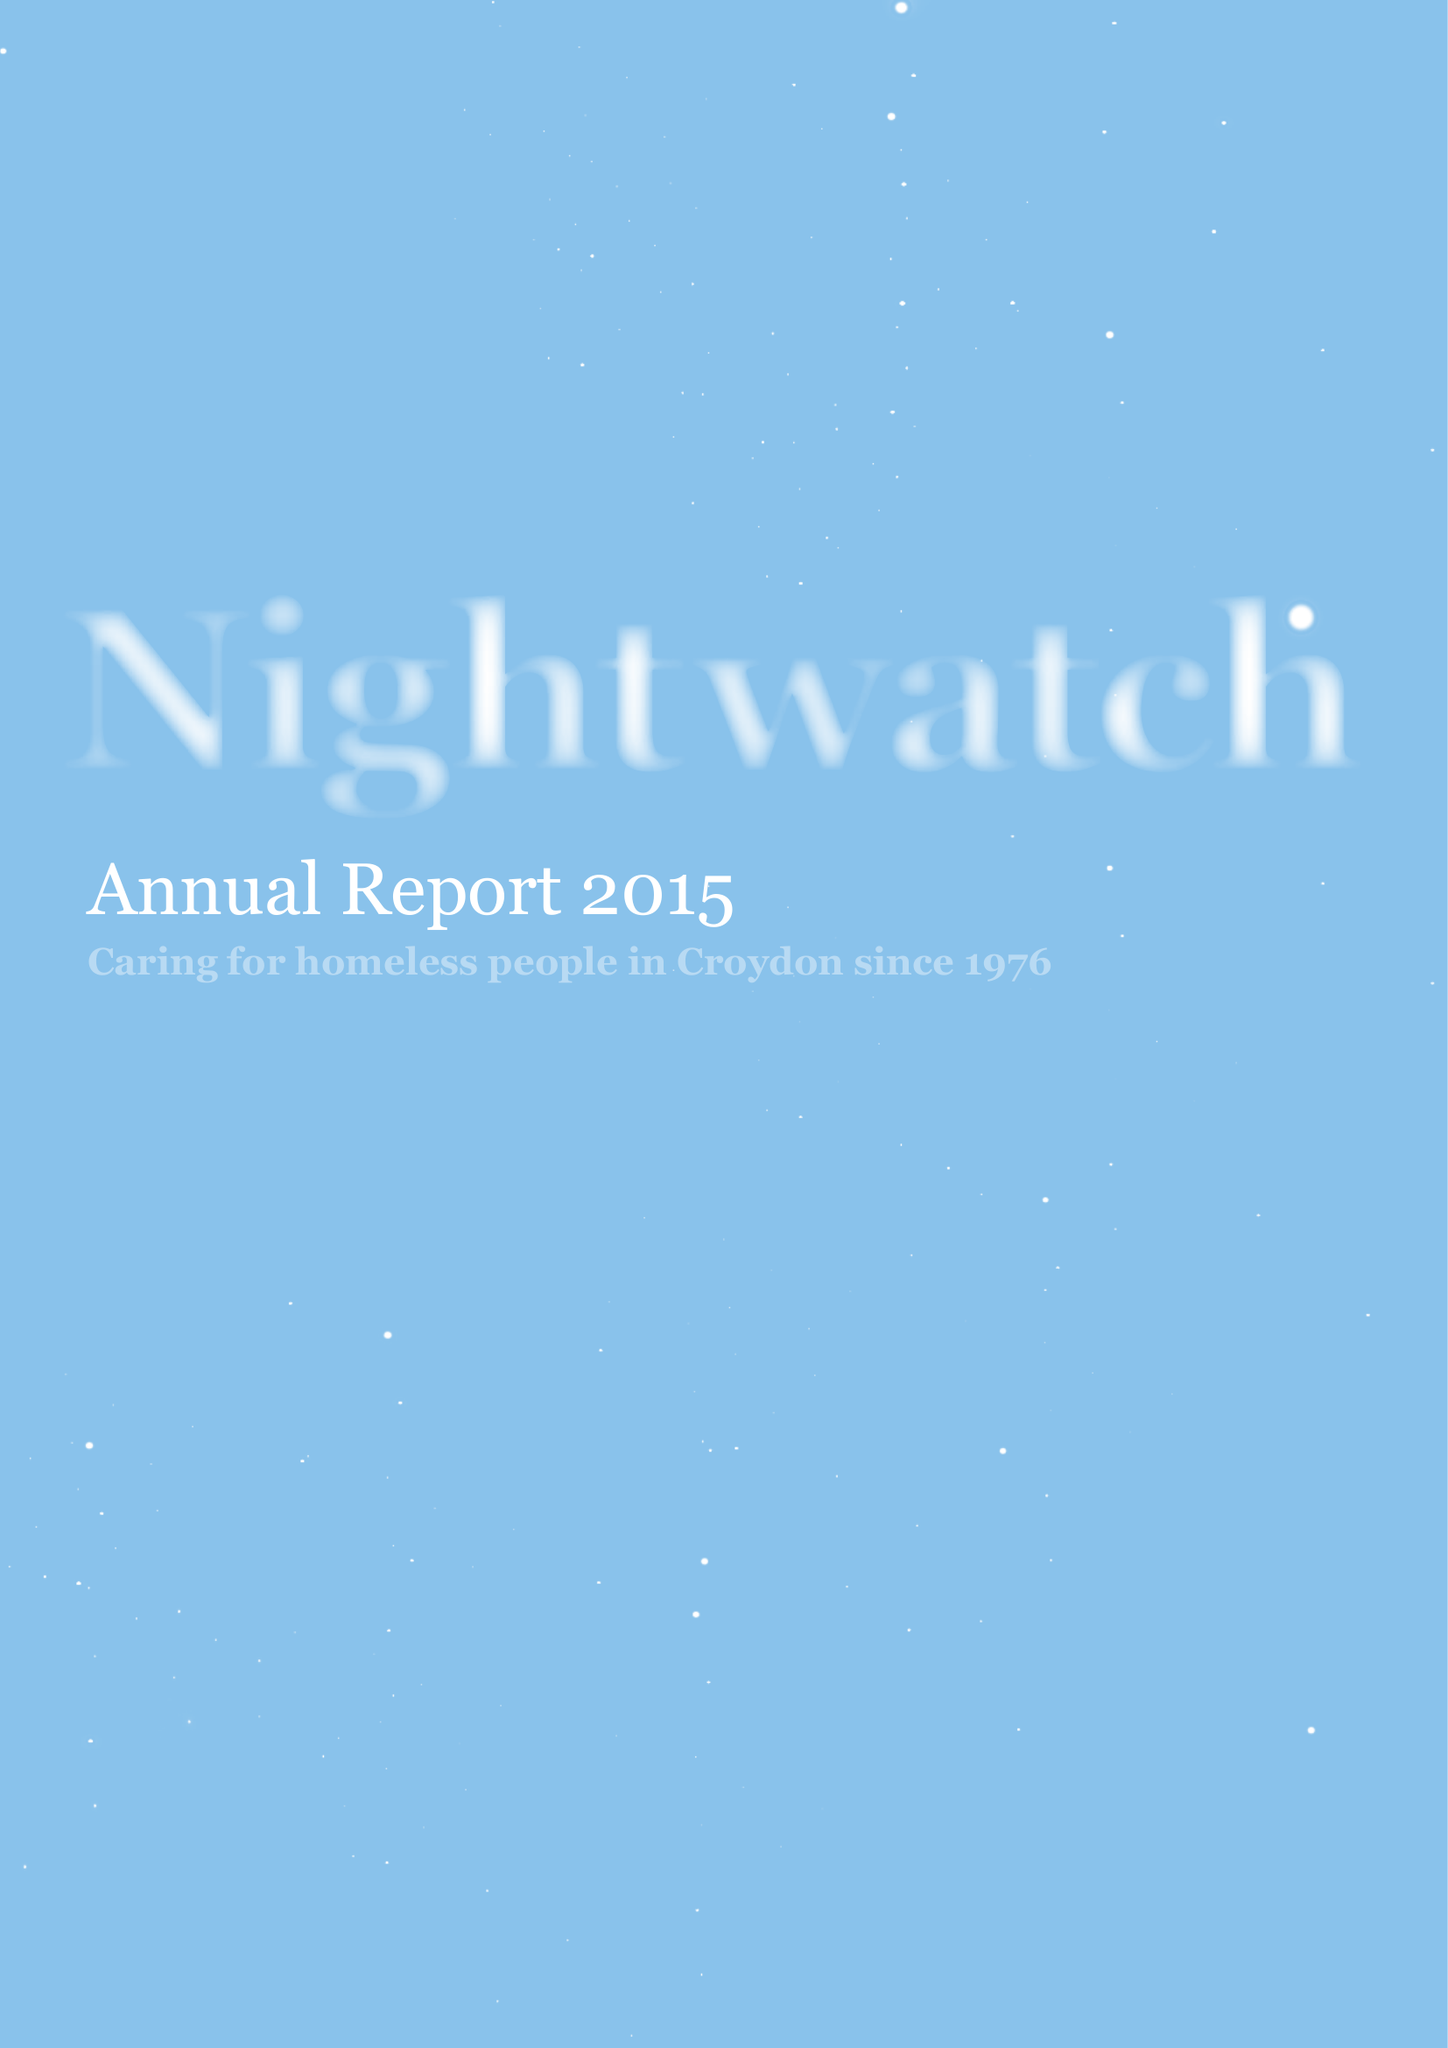What is the value for the charity_name?
Answer the question using a single word or phrase. Nightwatch 